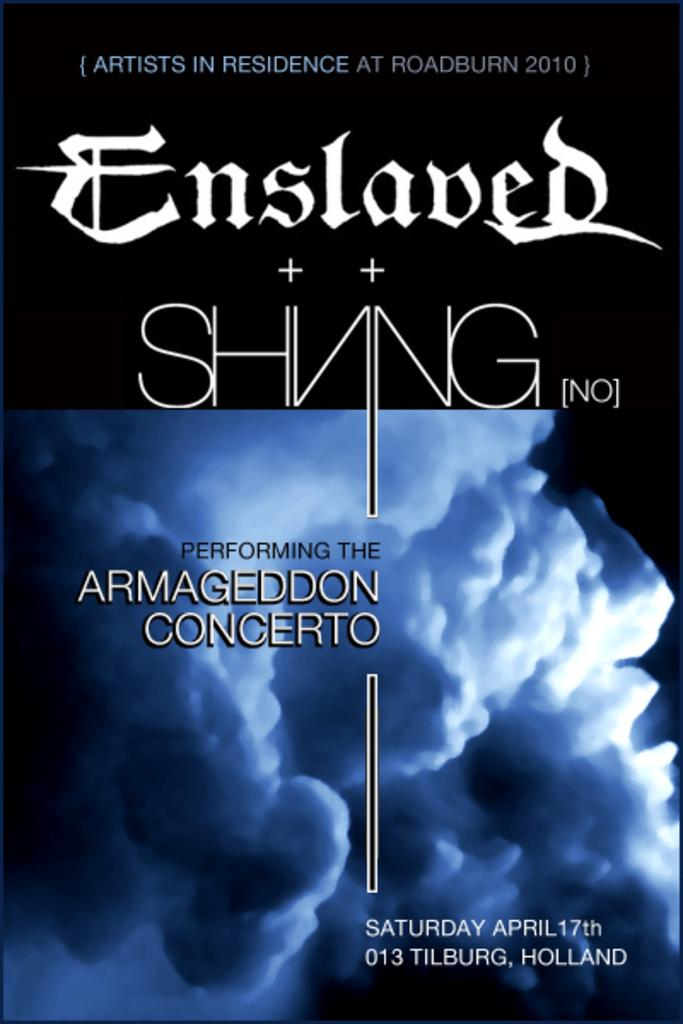Provide a one-sentence caption for the provided image. A program front cover announcing the performance of Armageddon Concerto. 